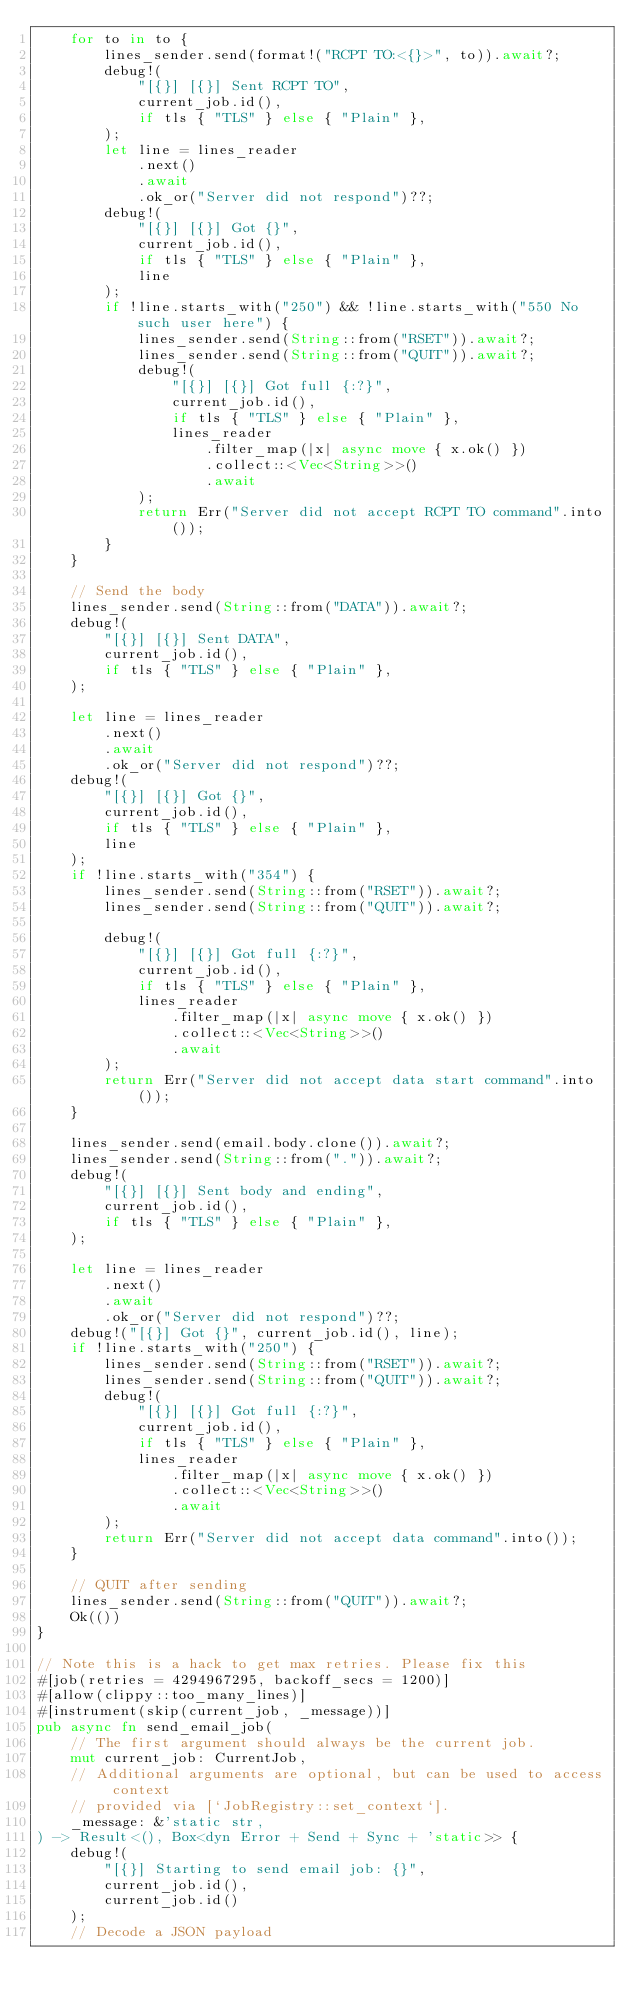<code> <loc_0><loc_0><loc_500><loc_500><_Rust_>    for to in to {
        lines_sender.send(format!("RCPT TO:<{}>", to)).await?;
        debug!(
            "[{}] [{}] Sent RCPT TO",
            current_job.id(),
            if tls { "TLS" } else { "Plain" },
        );
        let line = lines_reader
            .next()
            .await
            .ok_or("Server did not respond")??;
        debug!(
            "[{}] [{}] Got {}",
            current_job.id(),
            if tls { "TLS" } else { "Plain" },
            line
        );
        if !line.starts_with("250") && !line.starts_with("550 No such user here") {
            lines_sender.send(String::from("RSET")).await?;
            lines_sender.send(String::from("QUIT")).await?;
            debug!(
                "[{}] [{}] Got full {:?}",
                current_job.id(),
                if tls { "TLS" } else { "Plain" },
                lines_reader
                    .filter_map(|x| async move { x.ok() })
                    .collect::<Vec<String>>()
                    .await
            );
            return Err("Server did not accept RCPT TO command".into());
        }
    }

    // Send the body
    lines_sender.send(String::from("DATA")).await?;
    debug!(
        "[{}] [{}] Sent DATA",
        current_job.id(),
        if tls { "TLS" } else { "Plain" },
    );

    let line = lines_reader
        .next()
        .await
        .ok_or("Server did not respond")??;
    debug!(
        "[{}] [{}] Got {}",
        current_job.id(),
        if tls { "TLS" } else { "Plain" },
        line
    );
    if !line.starts_with("354") {
        lines_sender.send(String::from("RSET")).await?;
        lines_sender.send(String::from("QUIT")).await?;

        debug!(
            "[{}] [{}] Got full {:?}",
            current_job.id(),
            if tls { "TLS" } else { "Plain" },
            lines_reader
                .filter_map(|x| async move { x.ok() })
                .collect::<Vec<String>>()
                .await
        );
        return Err("Server did not accept data start command".into());
    }

    lines_sender.send(email.body.clone()).await?;
    lines_sender.send(String::from(".")).await?;
    debug!(
        "[{}] [{}] Sent body and ending",
        current_job.id(),
        if tls { "TLS" } else { "Plain" },
    );

    let line = lines_reader
        .next()
        .await
        .ok_or("Server did not respond")??;
    debug!("[{}] Got {}", current_job.id(), line);
    if !line.starts_with("250") {
        lines_sender.send(String::from("RSET")).await?;
        lines_sender.send(String::from("QUIT")).await?;
        debug!(
            "[{}] [{}] Got full {:?}",
            current_job.id(),
            if tls { "TLS" } else { "Plain" },
            lines_reader
                .filter_map(|x| async move { x.ok() })
                .collect::<Vec<String>>()
                .await
        );
        return Err("Server did not accept data command".into());
    }

    // QUIT after sending
    lines_sender.send(String::from("QUIT")).await?;
    Ok(())
}

// Note this is a hack to get max retries. Please fix this
#[job(retries = 4294967295, backoff_secs = 1200)]
#[allow(clippy::too_many_lines)]
#[instrument(skip(current_job, _message))]
pub async fn send_email_job(
    // The first argument should always be the current job.
    mut current_job: CurrentJob,
    // Additional arguments are optional, but can be used to access context
    // provided via [`JobRegistry::set_context`].
    _message: &'static str,
) -> Result<(), Box<dyn Error + Send + Sync + 'static>> {
    debug!(
        "[{}] Starting to send email job: {}",
        current_job.id(),
        current_job.id()
    );
    // Decode a JSON payload</code> 